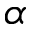<formula> <loc_0><loc_0><loc_500><loc_500>\alpha</formula> 